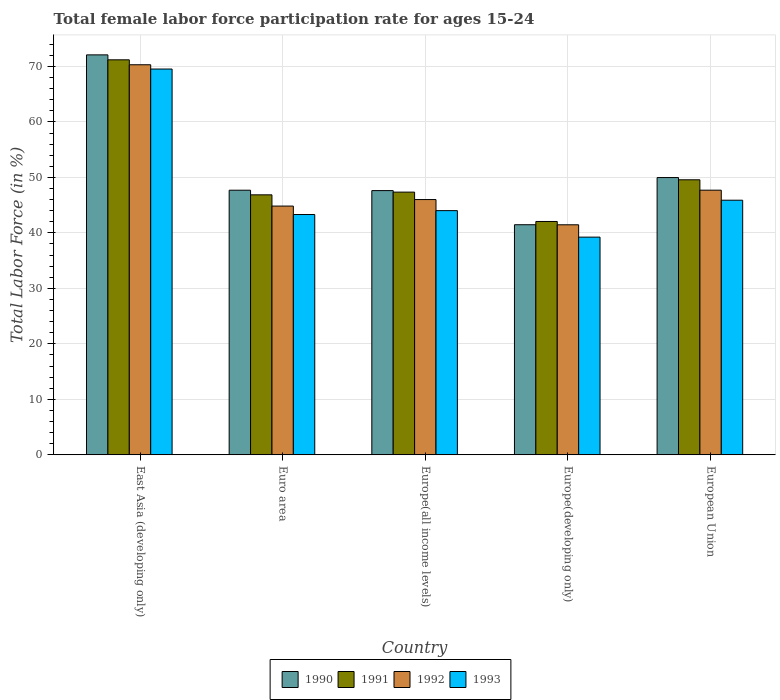How many groups of bars are there?
Your answer should be very brief. 5. How many bars are there on the 2nd tick from the left?
Ensure brevity in your answer.  4. What is the label of the 5th group of bars from the left?
Your answer should be very brief. European Union. What is the female labor force participation rate in 1993 in European Union?
Ensure brevity in your answer.  45.89. Across all countries, what is the maximum female labor force participation rate in 1991?
Your response must be concise. 71.19. Across all countries, what is the minimum female labor force participation rate in 1993?
Ensure brevity in your answer.  39.23. In which country was the female labor force participation rate in 1991 maximum?
Provide a succinct answer. East Asia (developing only). In which country was the female labor force participation rate in 1993 minimum?
Your answer should be compact. Europe(developing only). What is the total female labor force participation rate in 1992 in the graph?
Provide a short and direct response. 250.29. What is the difference between the female labor force participation rate in 1992 in Euro area and that in European Union?
Provide a succinct answer. -2.87. What is the difference between the female labor force participation rate in 1991 in European Union and the female labor force participation rate in 1990 in Europe(all income levels)?
Offer a very short reply. 1.95. What is the average female labor force participation rate in 1993 per country?
Give a very brief answer. 48.39. What is the difference between the female labor force participation rate of/in 1992 and female labor force participation rate of/in 1993 in Europe(developing only)?
Your answer should be compact. 2.23. What is the ratio of the female labor force participation rate in 1993 in East Asia (developing only) to that in Euro area?
Keep it short and to the point. 1.61. Is the difference between the female labor force participation rate in 1992 in East Asia (developing only) and Europe(all income levels) greater than the difference between the female labor force participation rate in 1993 in East Asia (developing only) and Europe(all income levels)?
Provide a succinct answer. No. What is the difference between the highest and the second highest female labor force participation rate in 1990?
Offer a very short reply. 22.11. What is the difference between the highest and the lowest female labor force participation rate in 1992?
Offer a very short reply. 28.84. In how many countries, is the female labor force participation rate in 1990 greater than the average female labor force participation rate in 1990 taken over all countries?
Provide a succinct answer. 1. Is it the case that in every country, the sum of the female labor force participation rate in 1992 and female labor force participation rate in 1991 is greater than the sum of female labor force participation rate in 1993 and female labor force participation rate in 1990?
Provide a succinct answer. No. How many bars are there?
Keep it short and to the point. 20. Are all the bars in the graph horizontal?
Provide a succinct answer. No. What is the difference between two consecutive major ticks on the Y-axis?
Your answer should be compact. 10. Does the graph contain any zero values?
Give a very brief answer. No. Does the graph contain grids?
Your answer should be compact. Yes. How many legend labels are there?
Your answer should be very brief. 4. How are the legend labels stacked?
Make the answer very short. Horizontal. What is the title of the graph?
Provide a succinct answer. Total female labor force participation rate for ages 15-24. Does "1997" appear as one of the legend labels in the graph?
Your answer should be very brief. No. What is the label or title of the X-axis?
Provide a succinct answer. Country. What is the label or title of the Y-axis?
Your answer should be compact. Total Labor Force (in %). What is the Total Labor Force (in %) in 1990 in East Asia (developing only)?
Offer a terse response. 72.08. What is the Total Labor Force (in %) of 1991 in East Asia (developing only)?
Give a very brief answer. 71.19. What is the Total Labor Force (in %) of 1992 in East Asia (developing only)?
Your response must be concise. 70.3. What is the Total Labor Force (in %) of 1993 in East Asia (developing only)?
Make the answer very short. 69.53. What is the Total Labor Force (in %) of 1990 in Euro area?
Offer a very short reply. 47.69. What is the Total Labor Force (in %) in 1991 in Euro area?
Provide a succinct answer. 46.86. What is the Total Labor Force (in %) of 1992 in Euro area?
Your response must be concise. 44.83. What is the Total Labor Force (in %) of 1993 in Euro area?
Your response must be concise. 43.31. What is the Total Labor Force (in %) in 1990 in Europe(all income levels)?
Your answer should be very brief. 47.62. What is the Total Labor Force (in %) in 1991 in Europe(all income levels)?
Your answer should be compact. 47.34. What is the Total Labor Force (in %) of 1992 in Europe(all income levels)?
Ensure brevity in your answer.  46. What is the Total Labor Force (in %) of 1993 in Europe(all income levels)?
Ensure brevity in your answer.  44.01. What is the Total Labor Force (in %) in 1990 in Europe(developing only)?
Give a very brief answer. 41.47. What is the Total Labor Force (in %) in 1991 in Europe(developing only)?
Your response must be concise. 42.05. What is the Total Labor Force (in %) in 1992 in Europe(developing only)?
Offer a very short reply. 41.46. What is the Total Labor Force (in %) of 1993 in Europe(developing only)?
Offer a very short reply. 39.23. What is the Total Labor Force (in %) in 1990 in European Union?
Your answer should be very brief. 49.97. What is the Total Labor Force (in %) of 1991 in European Union?
Ensure brevity in your answer.  49.57. What is the Total Labor Force (in %) of 1992 in European Union?
Keep it short and to the point. 47.7. What is the Total Labor Force (in %) in 1993 in European Union?
Offer a terse response. 45.89. Across all countries, what is the maximum Total Labor Force (in %) in 1990?
Offer a terse response. 72.08. Across all countries, what is the maximum Total Labor Force (in %) of 1991?
Your response must be concise. 71.19. Across all countries, what is the maximum Total Labor Force (in %) in 1992?
Provide a succinct answer. 70.3. Across all countries, what is the maximum Total Labor Force (in %) in 1993?
Give a very brief answer. 69.53. Across all countries, what is the minimum Total Labor Force (in %) of 1990?
Provide a short and direct response. 41.47. Across all countries, what is the minimum Total Labor Force (in %) of 1991?
Your response must be concise. 42.05. Across all countries, what is the minimum Total Labor Force (in %) in 1992?
Provide a short and direct response. 41.46. Across all countries, what is the minimum Total Labor Force (in %) of 1993?
Provide a succinct answer. 39.23. What is the total Total Labor Force (in %) of 1990 in the graph?
Ensure brevity in your answer.  258.83. What is the total Total Labor Force (in %) of 1991 in the graph?
Your answer should be very brief. 257.01. What is the total Total Labor Force (in %) of 1992 in the graph?
Give a very brief answer. 250.29. What is the total Total Labor Force (in %) in 1993 in the graph?
Your answer should be compact. 241.96. What is the difference between the Total Labor Force (in %) in 1990 in East Asia (developing only) and that in Euro area?
Give a very brief answer. 24.39. What is the difference between the Total Labor Force (in %) in 1991 in East Asia (developing only) and that in Euro area?
Make the answer very short. 24.34. What is the difference between the Total Labor Force (in %) of 1992 in East Asia (developing only) and that in Euro area?
Provide a succinct answer. 25.47. What is the difference between the Total Labor Force (in %) of 1993 in East Asia (developing only) and that in Euro area?
Make the answer very short. 26.22. What is the difference between the Total Labor Force (in %) in 1990 in East Asia (developing only) and that in Europe(all income levels)?
Give a very brief answer. 24.46. What is the difference between the Total Labor Force (in %) of 1991 in East Asia (developing only) and that in Europe(all income levels)?
Offer a very short reply. 23.85. What is the difference between the Total Labor Force (in %) of 1992 in East Asia (developing only) and that in Europe(all income levels)?
Provide a short and direct response. 24.3. What is the difference between the Total Labor Force (in %) in 1993 in East Asia (developing only) and that in Europe(all income levels)?
Provide a succinct answer. 25.52. What is the difference between the Total Labor Force (in %) of 1990 in East Asia (developing only) and that in Europe(developing only)?
Your answer should be very brief. 30.61. What is the difference between the Total Labor Force (in %) of 1991 in East Asia (developing only) and that in Europe(developing only)?
Provide a short and direct response. 29.14. What is the difference between the Total Labor Force (in %) in 1992 in East Asia (developing only) and that in Europe(developing only)?
Provide a succinct answer. 28.84. What is the difference between the Total Labor Force (in %) in 1993 in East Asia (developing only) and that in Europe(developing only)?
Your response must be concise. 30.3. What is the difference between the Total Labor Force (in %) in 1990 in East Asia (developing only) and that in European Union?
Make the answer very short. 22.11. What is the difference between the Total Labor Force (in %) of 1991 in East Asia (developing only) and that in European Union?
Make the answer very short. 21.62. What is the difference between the Total Labor Force (in %) of 1992 in East Asia (developing only) and that in European Union?
Provide a short and direct response. 22.61. What is the difference between the Total Labor Force (in %) in 1993 in East Asia (developing only) and that in European Union?
Ensure brevity in your answer.  23.64. What is the difference between the Total Labor Force (in %) of 1990 in Euro area and that in Europe(all income levels)?
Provide a short and direct response. 0.07. What is the difference between the Total Labor Force (in %) in 1991 in Euro area and that in Europe(all income levels)?
Make the answer very short. -0.49. What is the difference between the Total Labor Force (in %) in 1992 in Euro area and that in Europe(all income levels)?
Provide a short and direct response. -1.17. What is the difference between the Total Labor Force (in %) of 1993 in Euro area and that in Europe(all income levels)?
Provide a short and direct response. -0.7. What is the difference between the Total Labor Force (in %) in 1990 in Euro area and that in Europe(developing only)?
Make the answer very short. 6.22. What is the difference between the Total Labor Force (in %) in 1991 in Euro area and that in Europe(developing only)?
Ensure brevity in your answer.  4.8. What is the difference between the Total Labor Force (in %) in 1992 in Euro area and that in Europe(developing only)?
Offer a very short reply. 3.37. What is the difference between the Total Labor Force (in %) of 1993 in Euro area and that in Europe(developing only)?
Ensure brevity in your answer.  4.07. What is the difference between the Total Labor Force (in %) in 1990 in Euro area and that in European Union?
Offer a very short reply. -2.28. What is the difference between the Total Labor Force (in %) of 1991 in Euro area and that in European Union?
Your response must be concise. -2.71. What is the difference between the Total Labor Force (in %) of 1992 in Euro area and that in European Union?
Provide a short and direct response. -2.87. What is the difference between the Total Labor Force (in %) of 1993 in Euro area and that in European Union?
Your answer should be compact. -2.58. What is the difference between the Total Labor Force (in %) of 1990 in Europe(all income levels) and that in Europe(developing only)?
Offer a terse response. 6.15. What is the difference between the Total Labor Force (in %) of 1991 in Europe(all income levels) and that in Europe(developing only)?
Provide a succinct answer. 5.29. What is the difference between the Total Labor Force (in %) in 1992 in Europe(all income levels) and that in Europe(developing only)?
Ensure brevity in your answer.  4.55. What is the difference between the Total Labor Force (in %) in 1993 in Europe(all income levels) and that in Europe(developing only)?
Your answer should be compact. 4.78. What is the difference between the Total Labor Force (in %) in 1990 in Europe(all income levels) and that in European Union?
Provide a succinct answer. -2.35. What is the difference between the Total Labor Force (in %) of 1991 in Europe(all income levels) and that in European Union?
Make the answer very short. -2.22. What is the difference between the Total Labor Force (in %) in 1992 in Europe(all income levels) and that in European Union?
Your response must be concise. -1.69. What is the difference between the Total Labor Force (in %) of 1993 in Europe(all income levels) and that in European Union?
Ensure brevity in your answer.  -1.88. What is the difference between the Total Labor Force (in %) of 1990 in Europe(developing only) and that in European Union?
Keep it short and to the point. -8.5. What is the difference between the Total Labor Force (in %) of 1991 in Europe(developing only) and that in European Union?
Your response must be concise. -7.51. What is the difference between the Total Labor Force (in %) of 1992 in Europe(developing only) and that in European Union?
Provide a succinct answer. -6.24. What is the difference between the Total Labor Force (in %) of 1993 in Europe(developing only) and that in European Union?
Make the answer very short. -6.65. What is the difference between the Total Labor Force (in %) of 1990 in East Asia (developing only) and the Total Labor Force (in %) of 1991 in Euro area?
Your answer should be very brief. 25.23. What is the difference between the Total Labor Force (in %) in 1990 in East Asia (developing only) and the Total Labor Force (in %) in 1992 in Euro area?
Your answer should be compact. 27.25. What is the difference between the Total Labor Force (in %) in 1990 in East Asia (developing only) and the Total Labor Force (in %) in 1993 in Euro area?
Ensure brevity in your answer.  28.78. What is the difference between the Total Labor Force (in %) of 1991 in East Asia (developing only) and the Total Labor Force (in %) of 1992 in Euro area?
Provide a succinct answer. 26.36. What is the difference between the Total Labor Force (in %) in 1991 in East Asia (developing only) and the Total Labor Force (in %) in 1993 in Euro area?
Keep it short and to the point. 27.88. What is the difference between the Total Labor Force (in %) in 1992 in East Asia (developing only) and the Total Labor Force (in %) in 1993 in Euro area?
Provide a short and direct response. 27. What is the difference between the Total Labor Force (in %) of 1990 in East Asia (developing only) and the Total Labor Force (in %) of 1991 in Europe(all income levels)?
Keep it short and to the point. 24.74. What is the difference between the Total Labor Force (in %) in 1990 in East Asia (developing only) and the Total Labor Force (in %) in 1992 in Europe(all income levels)?
Give a very brief answer. 26.08. What is the difference between the Total Labor Force (in %) of 1990 in East Asia (developing only) and the Total Labor Force (in %) of 1993 in Europe(all income levels)?
Make the answer very short. 28.07. What is the difference between the Total Labor Force (in %) of 1991 in East Asia (developing only) and the Total Labor Force (in %) of 1992 in Europe(all income levels)?
Provide a short and direct response. 25.19. What is the difference between the Total Labor Force (in %) in 1991 in East Asia (developing only) and the Total Labor Force (in %) in 1993 in Europe(all income levels)?
Ensure brevity in your answer.  27.18. What is the difference between the Total Labor Force (in %) in 1992 in East Asia (developing only) and the Total Labor Force (in %) in 1993 in Europe(all income levels)?
Offer a very short reply. 26.29. What is the difference between the Total Labor Force (in %) in 1990 in East Asia (developing only) and the Total Labor Force (in %) in 1991 in Europe(developing only)?
Provide a short and direct response. 30.03. What is the difference between the Total Labor Force (in %) of 1990 in East Asia (developing only) and the Total Labor Force (in %) of 1992 in Europe(developing only)?
Keep it short and to the point. 30.63. What is the difference between the Total Labor Force (in %) in 1990 in East Asia (developing only) and the Total Labor Force (in %) in 1993 in Europe(developing only)?
Make the answer very short. 32.85. What is the difference between the Total Labor Force (in %) of 1991 in East Asia (developing only) and the Total Labor Force (in %) of 1992 in Europe(developing only)?
Your answer should be very brief. 29.73. What is the difference between the Total Labor Force (in %) of 1991 in East Asia (developing only) and the Total Labor Force (in %) of 1993 in Europe(developing only)?
Make the answer very short. 31.96. What is the difference between the Total Labor Force (in %) of 1992 in East Asia (developing only) and the Total Labor Force (in %) of 1993 in Europe(developing only)?
Your answer should be compact. 31.07. What is the difference between the Total Labor Force (in %) of 1990 in East Asia (developing only) and the Total Labor Force (in %) of 1991 in European Union?
Your answer should be very brief. 22.52. What is the difference between the Total Labor Force (in %) in 1990 in East Asia (developing only) and the Total Labor Force (in %) in 1992 in European Union?
Ensure brevity in your answer.  24.39. What is the difference between the Total Labor Force (in %) of 1990 in East Asia (developing only) and the Total Labor Force (in %) of 1993 in European Union?
Make the answer very short. 26.2. What is the difference between the Total Labor Force (in %) of 1991 in East Asia (developing only) and the Total Labor Force (in %) of 1992 in European Union?
Ensure brevity in your answer.  23.49. What is the difference between the Total Labor Force (in %) in 1991 in East Asia (developing only) and the Total Labor Force (in %) in 1993 in European Union?
Keep it short and to the point. 25.3. What is the difference between the Total Labor Force (in %) in 1992 in East Asia (developing only) and the Total Labor Force (in %) in 1993 in European Union?
Give a very brief answer. 24.42. What is the difference between the Total Labor Force (in %) in 1990 in Euro area and the Total Labor Force (in %) in 1991 in Europe(all income levels)?
Your answer should be very brief. 0.35. What is the difference between the Total Labor Force (in %) in 1990 in Euro area and the Total Labor Force (in %) in 1992 in Europe(all income levels)?
Make the answer very short. 1.69. What is the difference between the Total Labor Force (in %) in 1990 in Euro area and the Total Labor Force (in %) in 1993 in Europe(all income levels)?
Offer a terse response. 3.68. What is the difference between the Total Labor Force (in %) in 1991 in Euro area and the Total Labor Force (in %) in 1992 in Europe(all income levels)?
Make the answer very short. 0.85. What is the difference between the Total Labor Force (in %) in 1991 in Euro area and the Total Labor Force (in %) in 1993 in Europe(all income levels)?
Offer a very short reply. 2.85. What is the difference between the Total Labor Force (in %) in 1992 in Euro area and the Total Labor Force (in %) in 1993 in Europe(all income levels)?
Make the answer very short. 0.82. What is the difference between the Total Labor Force (in %) in 1990 in Euro area and the Total Labor Force (in %) in 1991 in Europe(developing only)?
Make the answer very short. 5.64. What is the difference between the Total Labor Force (in %) in 1990 in Euro area and the Total Labor Force (in %) in 1992 in Europe(developing only)?
Provide a succinct answer. 6.23. What is the difference between the Total Labor Force (in %) of 1990 in Euro area and the Total Labor Force (in %) of 1993 in Europe(developing only)?
Provide a succinct answer. 8.46. What is the difference between the Total Labor Force (in %) of 1991 in Euro area and the Total Labor Force (in %) of 1992 in Europe(developing only)?
Provide a succinct answer. 5.4. What is the difference between the Total Labor Force (in %) of 1991 in Euro area and the Total Labor Force (in %) of 1993 in Europe(developing only)?
Provide a short and direct response. 7.62. What is the difference between the Total Labor Force (in %) in 1992 in Euro area and the Total Labor Force (in %) in 1993 in Europe(developing only)?
Provide a succinct answer. 5.6. What is the difference between the Total Labor Force (in %) of 1990 in Euro area and the Total Labor Force (in %) of 1991 in European Union?
Give a very brief answer. -1.88. What is the difference between the Total Labor Force (in %) in 1990 in Euro area and the Total Labor Force (in %) in 1992 in European Union?
Provide a short and direct response. -0.01. What is the difference between the Total Labor Force (in %) in 1990 in Euro area and the Total Labor Force (in %) in 1993 in European Union?
Ensure brevity in your answer.  1.8. What is the difference between the Total Labor Force (in %) in 1991 in Euro area and the Total Labor Force (in %) in 1992 in European Union?
Offer a very short reply. -0.84. What is the difference between the Total Labor Force (in %) in 1991 in Euro area and the Total Labor Force (in %) in 1993 in European Union?
Your response must be concise. 0.97. What is the difference between the Total Labor Force (in %) in 1992 in Euro area and the Total Labor Force (in %) in 1993 in European Union?
Offer a terse response. -1.06. What is the difference between the Total Labor Force (in %) of 1990 in Europe(all income levels) and the Total Labor Force (in %) of 1991 in Europe(developing only)?
Make the answer very short. 5.56. What is the difference between the Total Labor Force (in %) in 1990 in Europe(all income levels) and the Total Labor Force (in %) in 1992 in Europe(developing only)?
Give a very brief answer. 6.16. What is the difference between the Total Labor Force (in %) of 1990 in Europe(all income levels) and the Total Labor Force (in %) of 1993 in Europe(developing only)?
Provide a short and direct response. 8.39. What is the difference between the Total Labor Force (in %) of 1991 in Europe(all income levels) and the Total Labor Force (in %) of 1992 in Europe(developing only)?
Ensure brevity in your answer.  5.89. What is the difference between the Total Labor Force (in %) in 1991 in Europe(all income levels) and the Total Labor Force (in %) in 1993 in Europe(developing only)?
Make the answer very short. 8.11. What is the difference between the Total Labor Force (in %) in 1992 in Europe(all income levels) and the Total Labor Force (in %) in 1993 in Europe(developing only)?
Your response must be concise. 6.77. What is the difference between the Total Labor Force (in %) of 1990 in Europe(all income levels) and the Total Labor Force (in %) of 1991 in European Union?
Provide a short and direct response. -1.95. What is the difference between the Total Labor Force (in %) of 1990 in Europe(all income levels) and the Total Labor Force (in %) of 1992 in European Union?
Provide a succinct answer. -0.08. What is the difference between the Total Labor Force (in %) of 1990 in Europe(all income levels) and the Total Labor Force (in %) of 1993 in European Union?
Make the answer very short. 1.73. What is the difference between the Total Labor Force (in %) of 1991 in Europe(all income levels) and the Total Labor Force (in %) of 1992 in European Union?
Your answer should be compact. -0.35. What is the difference between the Total Labor Force (in %) in 1991 in Europe(all income levels) and the Total Labor Force (in %) in 1993 in European Union?
Ensure brevity in your answer.  1.46. What is the difference between the Total Labor Force (in %) of 1992 in Europe(all income levels) and the Total Labor Force (in %) of 1993 in European Union?
Your answer should be compact. 0.12. What is the difference between the Total Labor Force (in %) in 1990 in Europe(developing only) and the Total Labor Force (in %) in 1991 in European Union?
Provide a succinct answer. -8.1. What is the difference between the Total Labor Force (in %) of 1990 in Europe(developing only) and the Total Labor Force (in %) of 1992 in European Union?
Provide a short and direct response. -6.23. What is the difference between the Total Labor Force (in %) in 1990 in Europe(developing only) and the Total Labor Force (in %) in 1993 in European Union?
Offer a terse response. -4.42. What is the difference between the Total Labor Force (in %) in 1991 in Europe(developing only) and the Total Labor Force (in %) in 1992 in European Union?
Keep it short and to the point. -5.64. What is the difference between the Total Labor Force (in %) in 1991 in Europe(developing only) and the Total Labor Force (in %) in 1993 in European Union?
Your response must be concise. -3.83. What is the difference between the Total Labor Force (in %) in 1992 in Europe(developing only) and the Total Labor Force (in %) in 1993 in European Union?
Provide a succinct answer. -4.43. What is the average Total Labor Force (in %) in 1990 per country?
Provide a short and direct response. 51.77. What is the average Total Labor Force (in %) in 1991 per country?
Offer a very short reply. 51.4. What is the average Total Labor Force (in %) of 1992 per country?
Provide a short and direct response. 50.06. What is the average Total Labor Force (in %) in 1993 per country?
Provide a short and direct response. 48.39. What is the difference between the Total Labor Force (in %) in 1990 and Total Labor Force (in %) in 1991 in East Asia (developing only)?
Your response must be concise. 0.89. What is the difference between the Total Labor Force (in %) of 1990 and Total Labor Force (in %) of 1992 in East Asia (developing only)?
Your answer should be very brief. 1.78. What is the difference between the Total Labor Force (in %) in 1990 and Total Labor Force (in %) in 1993 in East Asia (developing only)?
Offer a terse response. 2.55. What is the difference between the Total Labor Force (in %) in 1991 and Total Labor Force (in %) in 1992 in East Asia (developing only)?
Offer a terse response. 0.89. What is the difference between the Total Labor Force (in %) of 1991 and Total Labor Force (in %) of 1993 in East Asia (developing only)?
Offer a very short reply. 1.66. What is the difference between the Total Labor Force (in %) of 1992 and Total Labor Force (in %) of 1993 in East Asia (developing only)?
Provide a short and direct response. 0.77. What is the difference between the Total Labor Force (in %) in 1990 and Total Labor Force (in %) in 1991 in Euro area?
Keep it short and to the point. 0.83. What is the difference between the Total Labor Force (in %) in 1990 and Total Labor Force (in %) in 1992 in Euro area?
Offer a very short reply. 2.86. What is the difference between the Total Labor Force (in %) of 1990 and Total Labor Force (in %) of 1993 in Euro area?
Offer a terse response. 4.38. What is the difference between the Total Labor Force (in %) of 1991 and Total Labor Force (in %) of 1992 in Euro area?
Provide a succinct answer. 2.02. What is the difference between the Total Labor Force (in %) of 1991 and Total Labor Force (in %) of 1993 in Euro area?
Give a very brief answer. 3.55. What is the difference between the Total Labor Force (in %) of 1992 and Total Labor Force (in %) of 1993 in Euro area?
Offer a terse response. 1.52. What is the difference between the Total Labor Force (in %) in 1990 and Total Labor Force (in %) in 1991 in Europe(all income levels)?
Your answer should be very brief. 0.27. What is the difference between the Total Labor Force (in %) in 1990 and Total Labor Force (in %) in 1992 in Europe(all income levels)?
Give a very brief answer. 1.61. What is the difference between the Total Labor Force (in %) in 1990 and Total Labor Force (in %) in 1993 in Europe(all income levels)?
Your answer should be very brief. 3.61. What is the difference between the Total Labor Force (in %) in 1991 and Total Labor Force (in %) in 1992 in Europe(all income levels)?
Keep it short and to the point. 1.34. What is the difference between the Total Labor Force (in %) in 1991 and Total Labor Force (in %) in 1993 in Europe(all income levels)?
Your answer should be compact. 3.34. What is the difference between the Total Labor Force (in %) of 1992 and Total Labor Force (in %) of 1993 in Europe(all income levels)?
Provide a succinct answer. 1.99. What is the difference between the Total Labor Force (in %) of 1990 and Total Labor Force (in %) of 1991 in Europe(developing only)?
Provide a succinct answer. -0.59. What is the difference between the Total Labor Force (in %) in 1990 and Total Labor Force (in %) in 1992 in Europe(developing only)?
Make the answer very short. 0.01. What is the difference between the Total Labor Force (in %) of 1990 and Total Labor Force (in %) of 1993 in Europe(developing only)?
Make the answer very short. 2.24. What is the difference between the Total Labor Force (in %) of 1991 and Total Labor Force (in %) of 1992 in Europe(developing only)?
Keep it short and to the point. 0.6. What is the difference between the Total Labor Force (in %) of 1991 and Total Labor Force (in %) of 1993 in Europe(developing only)?
Your answer should be compact. 2.82. What is the difference between the Total Labor Force (in %) in 1992 and Total Labor Force (in %) in 1993 in Europe(developing only)?
Your answer should be very brief. 2.23. What is the difference between the Total Labor Force (in %) in 1990 and Total Labor Force (in %) in 1991 in European Union?
Offer a terse response. 0.4. What is the difference between the Total Labor Force (in %) in 1990 and Total Labor Force (in %) in 1992 in European Union?
Your response must be concise. 2.27. What is the difference between the Total Labor Force (in %) in 1990 and Total Labor Force (in %) in 1993 in European Union?
Provide a short and direct response. 4.08. What is the difference between the Total Labor Force (in %) of 1991 and Total Labor Force (in %) of 1992 in European Union?
Offer a very short reply. 1.87. What is the difference between the Total Labor Force (in %) in 1991 and Total Labor Force (in %) in 1993 in European Union?
Ensure brevity in your answer.  3.68. What is the difference between the Total Labor Force (in %) in 1992 and Total Labor Force (in %) in 1993 in European Union?
Keep it short and to the point. 1.81. What is the ratio of the Total Labor Force (in %) in 1990 in East Asia (developing only) to that in Euro area?
Your response must be concise. 1.51. What is the ratio of the Total Labor Force (in %) of 1991 in East Asia (developing only) to that in Euro area?
Your answer should be compact. 1.52. What is the ratio of the Total Labor Force (in %) in 1992 in East Asia (developing only) to that in Euro area?
Provide a short and direct response. 1.57. What is the ratio of the Total Labor Force (in %) in 1993 in East Asia (developing only) to that in Euro area?
Your response must be concise. 1.61. What is the ratio of the Total Labor Force (in %) of 1990 in East Asia (developing only) to that in Europe(all income levels)?
Your response must be concise. 1.51. What is the ratio of the Total Labor Force (in %) of 1991 in East Asia (developing only) to that in Europe(all income levels)?
Provide a succinct answer. 1.5. What is the ratio of the Total Labor Force (in %) in 1992 in East Asia (developing only) to that in Europe(all income levels)?
Provide a short and direct response. 1.53. What is the ratio of the Total Labor Force (in %) of 1993 in East Asia (developing only) to that in Europe(all income levels)?
Give a very brief answer. 1.58. What is the ratio of the Total Labor Force (in %) in 1990 in East Asia (developing only) to that in Europe(developing only)?
Offer a very short reply. 1.74. What is the ratio of the Total Labor Force (in %) in 1991 in East Asia (developing only) to that in Europe(developing only)?
Provide a succinct answer. 1.69. What is the ratio of the Total Labor Force (in %) of 1992 in East Asia (developing only) to that in Europe(developing only)?
Give a very brief answer. 1.7. What is the ratio of the Total Labor Force (in %) of 1993 in East Asia (developing only) to that in Europe(developing only)?
Your answer should be compact. 1.77. What is the ratio of the Total Labor Force (in %) in 1990 in East Asia (developing only) to that in European Union?
Provide a succinct answer. 1.44. What is the ratio of the Total Labor Force (in %) in 1991 in East Asia (developing only) to that in European Union?
Ensure brevity in your answer.  1.44. What is the ratio of the Total Labor Force (in %) in 1992 in East Asia (developing only) to that in European Union?
Offer a very short reply. 1.47. What is the ratio of the Total Labor Force (in %) of 1993 in East Asia (developing only) to that in European Union?
Keep it short and to the point. 1.52. What is the ratio of the Total Labor Force (in %) of 1990 in Euro area to that in Europe(all income levels)?
Offer a terse response. 1. What is the ratio of the Total Labor Force (in %) in 1992 in Euro area to that in Europe(all income levels)?
Your answer should be very brief. 0.97. What is the ratio of the Total Labor Force (in %) in 1990 in Euro area to that in Europe(developing only)?
Make the answer very short. 1.15. What is the ratio of the Total Labor Force (in %) of 1991 in Euro area to that in Europe(developing only)?
Keep it short and to the point. 1.11. What is the ratio of the Total Labor Force (in %) in 1992 in Euro area to that in Europe(developing only)?
Give a very brief answer. 1.08. What is the ratio of the Total Labor Force (in %) of 1993 in Euro area to that in Europe(developing only)?
Give a very brief answer. 1.1. What is the ratio of the Total Labor Force (in %) in 1990 in Euro area to that in European Union?
Provide a succinct answer. 0.95. What is the ratio of the Total Labor Force (in %) in 1991 in Euro area to that in European Union?
Ensure brevity in your answer.  0.95. What is the ratio of the Total Labor Force (in %) in 1992 in Euro area to that in European Union?
Offer a very short reply. 0.94. What is the ratio of the Total Labor Force (in %) in 1993 in Euro area to that in European Union?
Provide a short and direct response. 0.94. What is the ratio of the Total Labor Force (in %) of 1990 in Europe(all income levels) to that in Europe(developing only)?
Your response must be concise. 1.15. What is the ratio of the Total Labor Force (in %) of 1991 in Europe(all income levels) to that in Europe(developing only)?
Your response must be concise. 1.13. What is the ratio of the Total Labor Force (in %) of 1992 in Europe(all income levels) to that in Europe(developing only)?
Provide a succinct answer. 1.11. What is the ratio of the Total Labor Force (in %) of 1993 in Europe(all income levels) to that in Europe(developing only)?
Offer a very short reply. 1.12. What is the ratio of the Total Labor Force (in %) in 1990 in Europe(all income levels) to that in European Union?
Your answer should be compact. 0.95. What is the ratio of the Total Labor Force (in %) of 1991 in Europe(all income levels) to that in European Union?
Provide a succinct answer. 0.96. What is the ratio of the Total Labor Force (in %) in 1992 in Europe(all income levels) to that in European Union?
Your answer should be very brief. 0.96. What is the ratio of the Total Labor Force (in %) of 1993 in Europe(all income levels) to that in European Union?
Offer a very short reply. 0.96. What is the ratio of the Total Labor Force (in %) in 1990 in Europe(developing only) to that in European Union?
Your answer should be compact. 0.83. What is the ratio of the Total Labor Force (in %) in 1991 in Europe(developing only) to that in European Union?
Provide a succinct answer. 0.85. What is the ratio of the Total Labor Force (in %) in 1992 in Europe(developing only) to that in European Union?
Make the answer very short. 0.87. What is the ratio of the Total Labor Force (in %) in 1993 in Europe(developing only) to that in European Union?
Give a very brief answer. 0.85. What is the difference between the highest and the second highest Total Labor Force (in %) in 1990?
Your response must be concise. 22.11. What is the difference between the highest and the second highest Total Labor Force (in %) of 1991?
Keep it short and to the point. 21.62. What is the difference between the highest and the second highest Total Labor Force (in %) in 1992?
Offer a very short reply. 22.61. What is the difference between the highest and the second highest Total Labor Force (in %) in 1993?
Your answer should be compact. 23.64. What is the difference between the highest and the lowest Total Labor Force (in %) in 1990?
Your response must be concise. 30.61. What is the difference between the highest and the lowest Total Labor Force (in %) of 1991?
Give a very brief answer. 29.14. What is the difference between the highest and the lowest Total Labor Force (in %) in 1992?
Ensure brevity in your answer.  28.84. What is the difference between the highest and the lowest Total Labor Force (in %) of 1993?
Give a very brief answer. 30.3. 